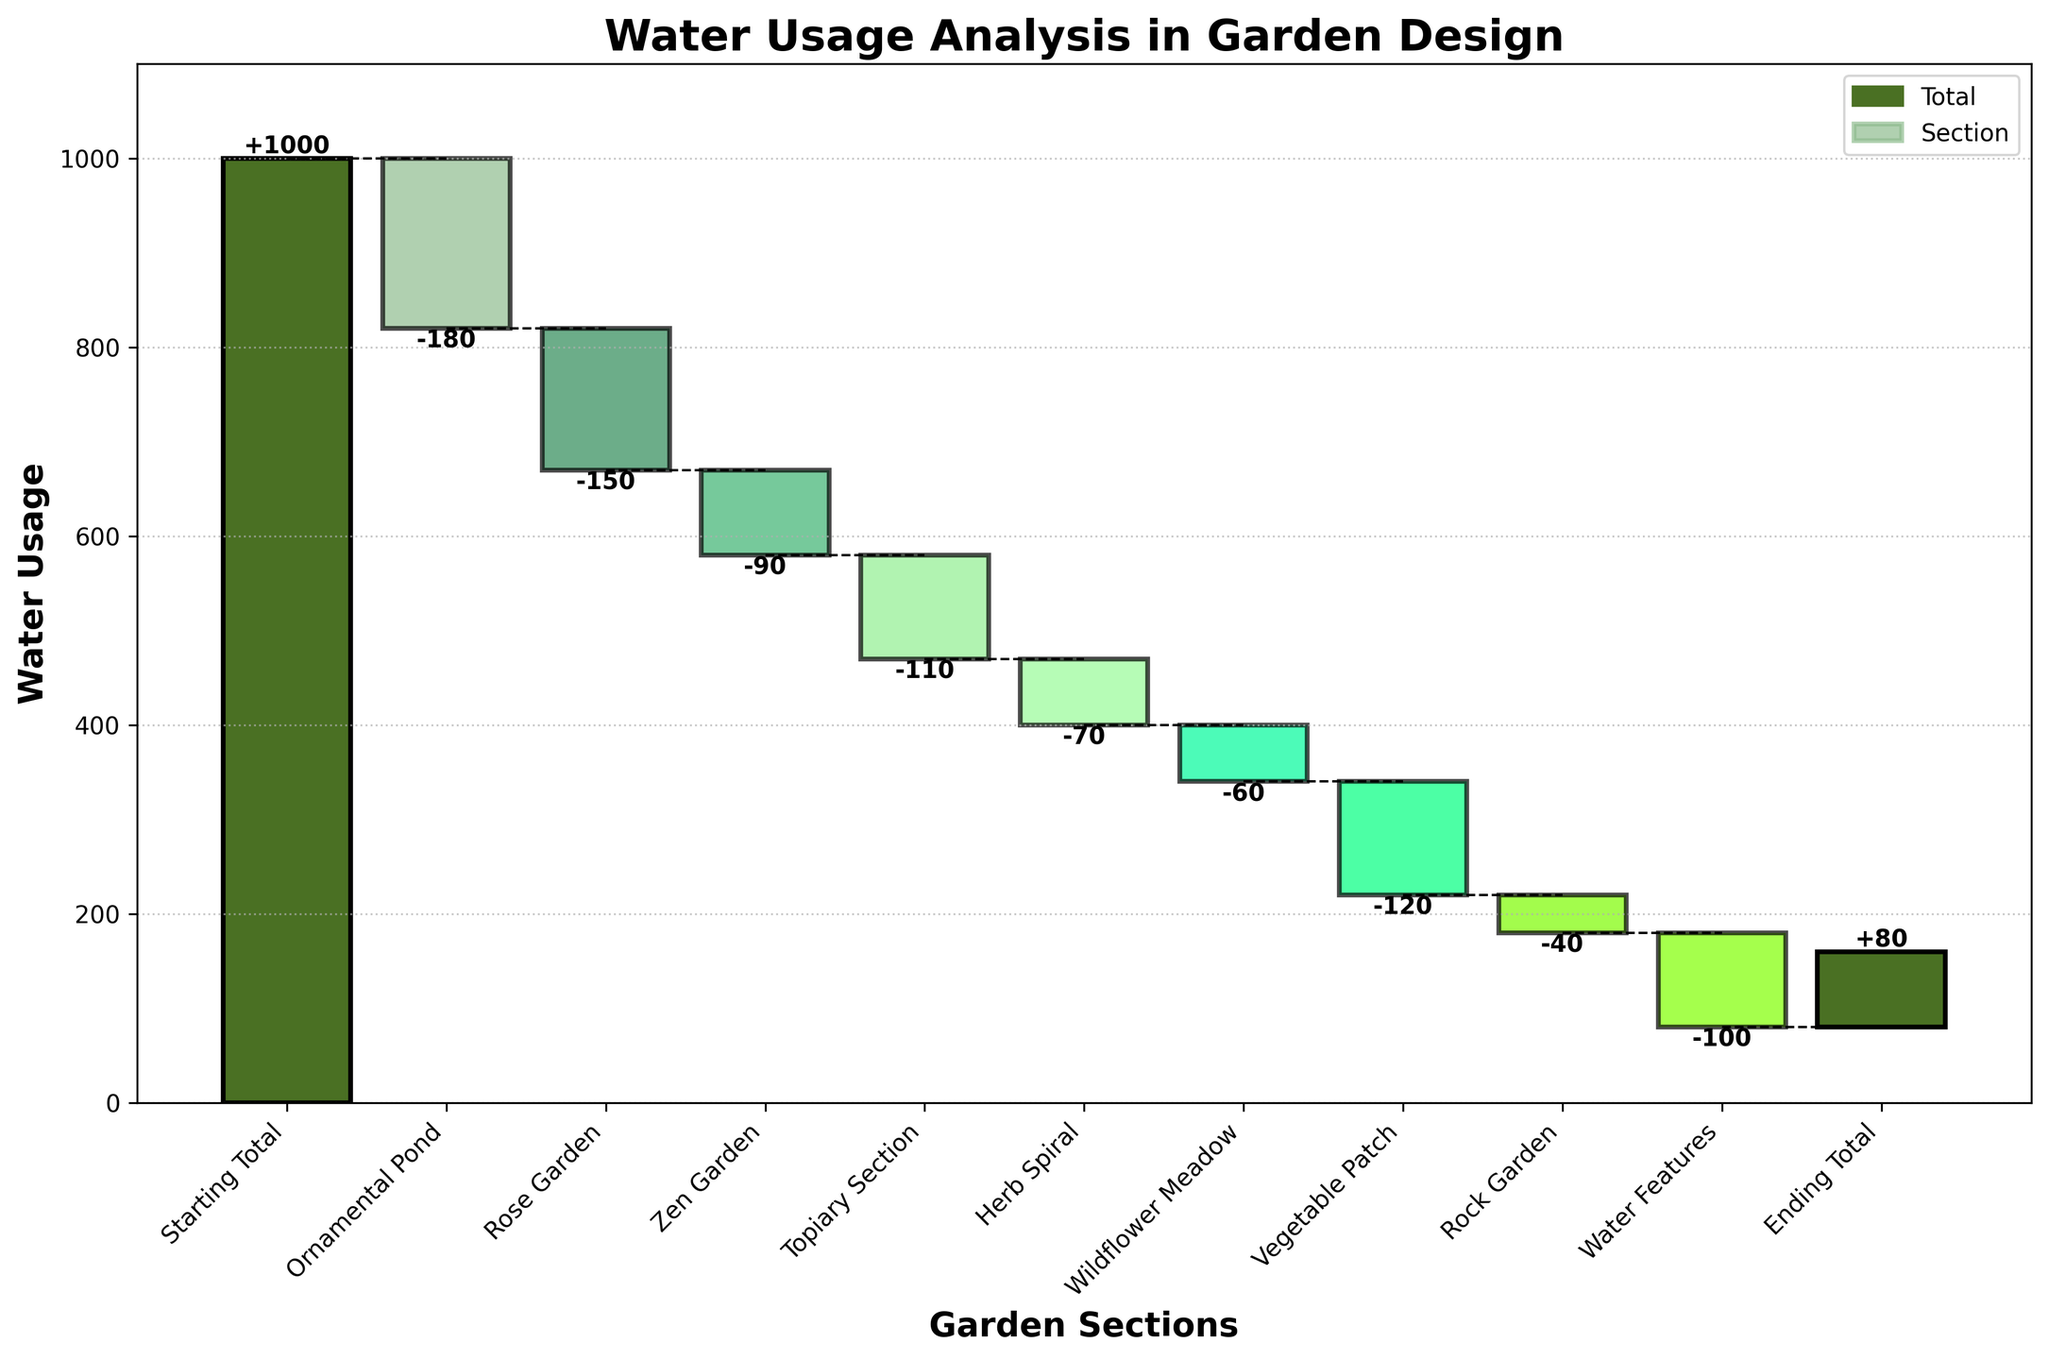How many garden sections are analyzed in the figure? Count the number of garden sections listed on the x-axis, excluding the starting and ending totals. There are 8 sections: Ornamental Pond, Rose Garden, Zen Garden, Topiary Section, Herb Spiral, Wildflower Meadow, Vegetable Patch, and Rock Garden.
Answer: 8 Which section has the highest water usage? Identify the section with the smallest negative value, indicating the least water reduction. The Rock Garden has the smallest negative value of -40.
Answer: Rock Garden What is the sum of water usage for the Ornamental Pond and Rose Garden? Add the negative values of the Ornamental Pond and Rose Garden: -180 + -150 = -330.
Answer: -330 How does the water usage in the Zen Garden compare to the Herb Spiral? Compare the values: Zen Garden uses -90 units of water, while Herb Spiral uses -70 units. The Herb Spiral uses less water than the Zen Garden.
Answer: Herb Spiral uses less What is the cumulative water usage before reaching the Vegetable Patch? Cumulatively add values step by step from the starting total to the Vegetable Patch: 1000 (Starting Total) - 180 (Ornamental Pond) - 150 (Rose Garden) - 90 (Zen Garden) - 110 (Topiary Section) - 70 (Herb Spiral) - 60 (Wildflower Meadow) = 340.
Answer: 340 How much total water is saved after accounting for usage in all the sections? The ending total represents the amount of water remaining after all sections' usage is accounted for. The ending total is 80 units of water.
Answer: 80 What is the range of water usage values among the sections? Find the difference between the largest and smallest values. The largest negative value is -180 (Ornamental Pond), and the smallest negative value is -40 (Rock Garden). The range is -40 - (-180) = 140.
Answer: 140 Which section reduced water usage more than the Vegetable Patch but less than the Ornamental Pond? Compare the values: Ornamental Pond (-180), Vegetable Patch (-120). The sections that fit this criteria with values between -180 and -120 are Topiary Section (-110), Zen Garden (-90), Herb Spiral (-70), Wildflower Meadow (-60), and Rock Garden (-40).
Answer: Topiary Section, Zen Garden, Herb Spiral, Wildflower Meadow, Rock Garden How many sections have a water usage value greater than -100? Count the number of sections with values greater than -100: Zen Garden (-90), Herb Spiral (-70), Wildflower Meadow (-60), Rock Garden (-40). There are 4 sections.
Answer: 4 Is the total usage in the Topiary Section more or less than the combined usage of the Rock Garden and Water Features? Compare the values directly: Topiary Section (-110), Rock Garden (-40), and Water Features (-100). Sum of Rock Garden and Water Features is -40 + -100 = -140, which is less than -110.
Answer: Less 